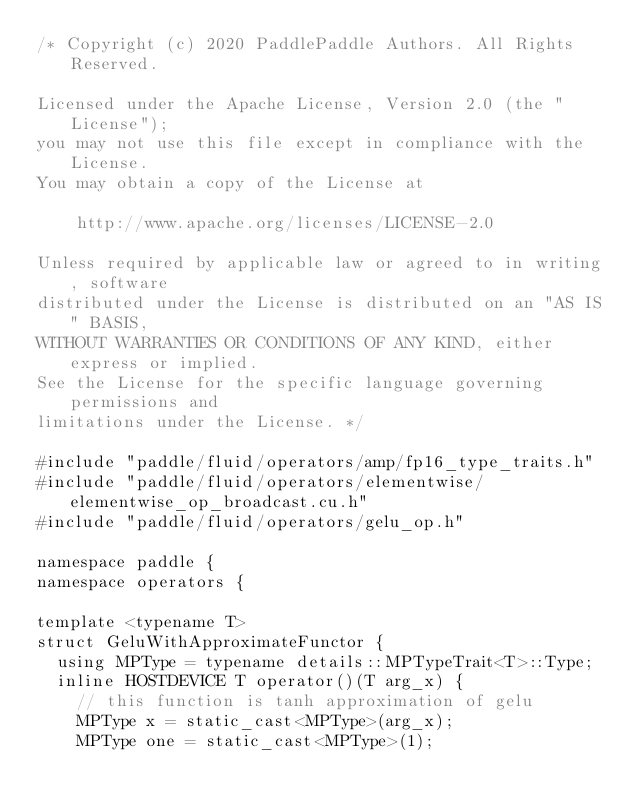<code> <loc_0><loc_0><loc_500><loc_500><_Cuda_>/* Copyright (c) 2020 PaddlePaddle Authors. All Rights Reserved.

Licensed under the Apache License, Version 2.0 (the "License");
you may not use this file except in compliance with the License.
You may obtain a copy of the License at

    http://www.apache.org/licenses/LICENSE-2.0

Unless required by applicable law or agreed to in writing, software
distributed under the License is distributed on an "AS IS" BASIS,
WITHOUT WARRANTIES OR CONDITIONS OF ANY KIND, either express or implied.
See the License for the specific language governing permissions and
limitations under the License. */

#include "paddle/fluid/operators/amp/fp16_type_traits.h"
#include "paddle/fluid/operators/elementwise/elementwise_op_broadcast.cu.h"
#include "paddle/fluid/operators/gelu_op.h"

namespace paddle {
namespace operators {

template <typename T>
struct GeluWithApproximateFunctor {
  using MPType = typename details::MPTypeTrait<T>::Type;
  inline HOSTDEVICE T operator()(T arg_x) {
    // this function is tanh approximation of gelu
    MPType x = static_cast<MPType>(arg_x);
    MPType one = static_cast<MPType>(1);</code> 